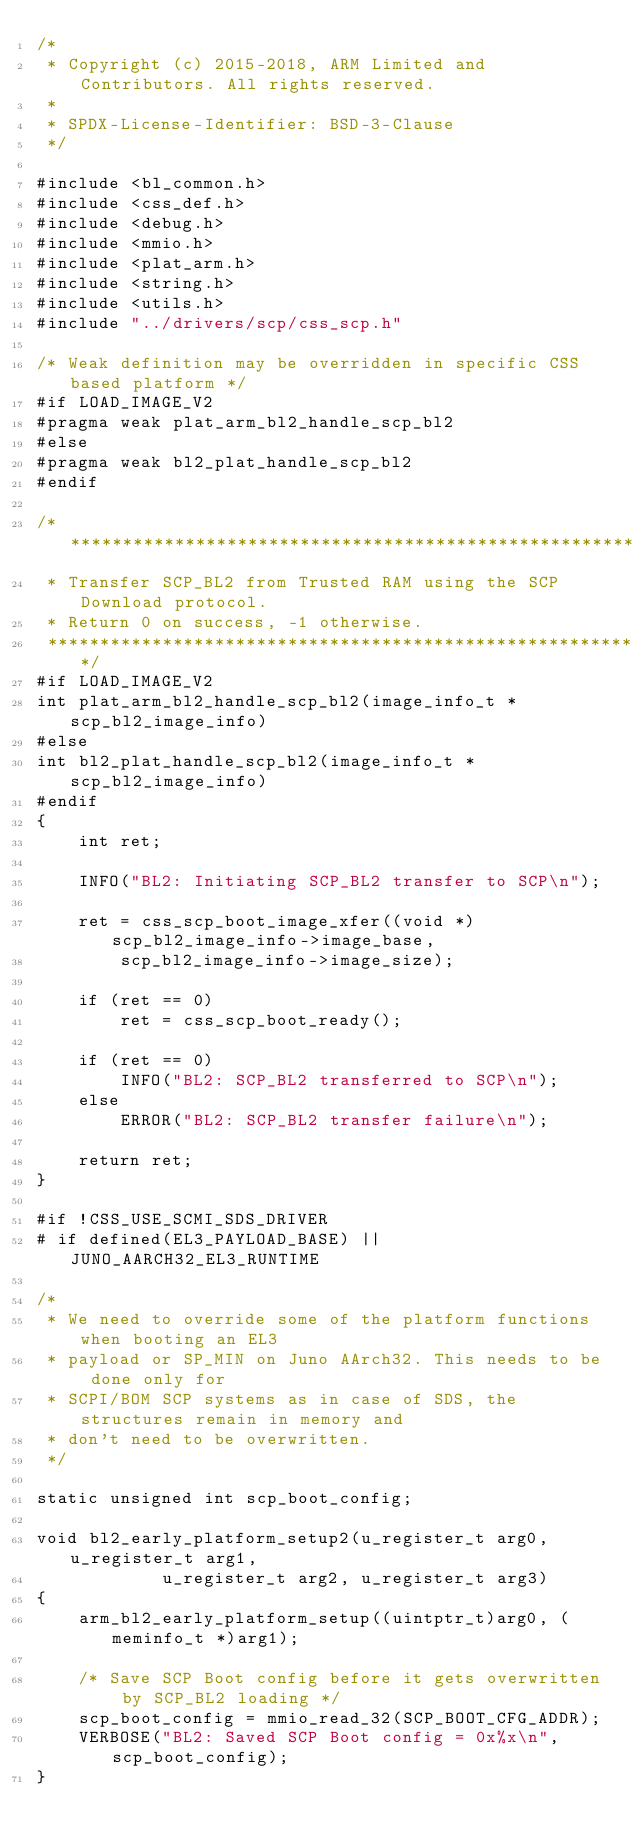Convert code to text. <code><loc_0><loc_0><loc_500><loc_500><_C_>/*
 * Copyright (c) 2015-2018, ARM Limited and Contributors. All rights reserved.
 *
 * SPDX-License-Identifier: BSD-3-Clause
 */

#include <bl_common.h>
#include <css_def.h>
#include <debug.h>
#include <mmio.h>
#include <plat_arm.h>
#include <string.h>
#include <utils.h>
#include "../drivers/scp/css_scp.h"

/* Weak definition may be overridden in specific CSS based platform */
#if LOAD_IMAGE_V2
#pragma weak plat_arm_bl2_handle_scp_bl2
#else
#pragma weak bl2_plat_handle_scp_bl2
#endif

/*******************************************************************************
 * Transfer SCP_BL2 from Trusted RAM using the SCP Download protocol.
 * Return 0 on success, -1 otherwise.
 ******************************************************************************/
#if LOAD_IMAGE_V2
int plat_arm_bl2_handle_scp_bl2(image_info_t *scp_bl2_image_info)
#else
int bl2_plat_handle_scp_bl2(image_info_t *scp_bl2_image_info)
#endif
{
	int ret;

	INFO("BL2: Initiating SCP_BL2 transfer to SCP\n");

	ret = css_scp_boot_image_xfer((void *)scp_bl2_image_info->image_base,
		scp_bl2_image_info->image_size);

	if (ret == 0)
		ret = css_scp_boot_ready();

	if (ret == 0)
		INFO("BL2: SCP_BL2 transferred to SCP\n");
	else
		ERROR("BL2: SCP_BL2 transfer failure\n");

	return ret;
}

#if !CSS_USE_SCMI_SDS_DRIVER
# if defined(EL3_PAYLOAD_BASE) || JUNO_AARCH32_EL3_RUNTIME

/*
 * We need to override some of the platform functions when booting an EL3
 * payload or SP_MIN on Juno AArch32. This needs to be done only for
 * SCPI/BOM SCP systems as in case of SDS, the structures remain in memory and
 * don't need to be overwritten.
 */

static unsigned int scp_boot_config;

void bl2_early_platform_setup2(u_register_t arg0, u_register_t arg1,
			u_register_t arg2, u_register_t arg3)
{
	arm_bl2_early_platform_setup((uintptr_t)arg0, (meminfo_t *)arg1);

	/* Save SCP Boot config before it gets overwritten by SCP_BL2 loading */
	scp_boot_config = mmio_read_32(SCP_BOOT_CFG_ADDR);
	VERBOSE("BL2: Saved SCP Boot config = 0x%x\n", scp_boot_config);
}
</code> 